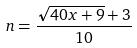<formula> <loc_0><loc_0><loc_500><loc_500>n = \frac { \sqrt { 4 0 x + 9 } + 3 } { 1 0 }</formula> 